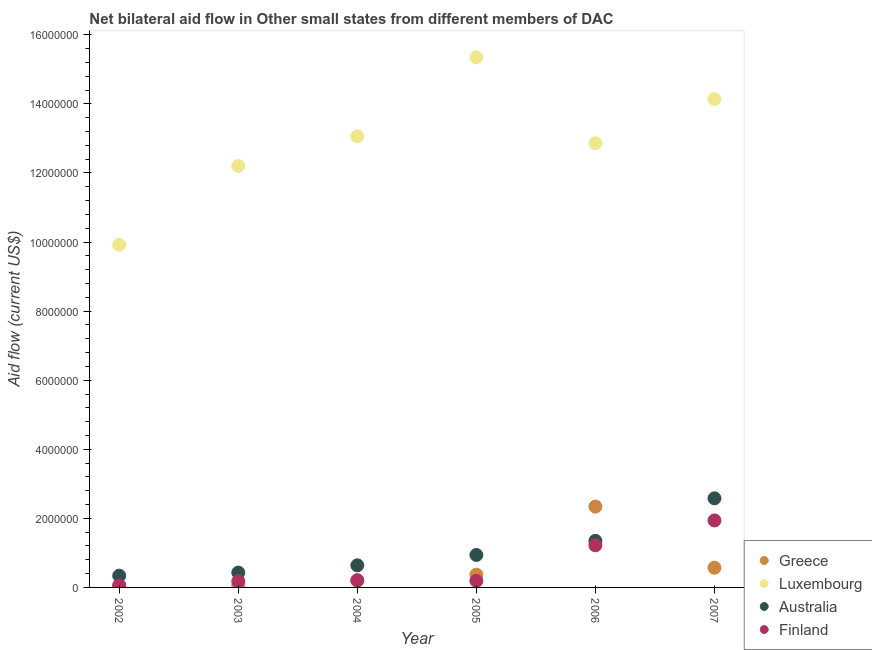Is the number of dotlines equal to the number of legend labels?
Keep it short and to the point. Yes. What is the amount of aid given by greece in 2007?
Your answer should be compact. 5.70e+05. Across all years, what is the maximum amount of aid given by finland?
Keep it short and to the point. 1.94e+06. Across all years, what is the minimum amount of aid given by greece?
Offer a very short reply. 5.00e+04. What is the total amount of aid given by luxembourg in the graph?
Make the answer very short. 7.75e+07. What is the difference between the amount of aid given by luxembourg in 2006 and that in 2007?
Make the answer very short. -1.28e+06. What is the difference between the amount of aid given by australia in 2007 and the amount of aid given by luxembourg in 2006?
Give a very brief answer. -1.03e+07. What is the average amount of aid given by greece per year?
Your answer should be very brief. 5.95e+05. In the year 2002, what is the difference between the amount of aid given by australia and amount of aid given by luxembourg?
Keep it short and to the point. -9.58e+06. In how many years, is the amount of aid given by finland greater than 13200000 US$?
Your response must be concise. 0. What is the ratio of the amount of aid given by greece in 2002 to that in 2006?
Your response must be concise. 0.02. Is the difference between the amount of aid given by luxembourg in 2004 and 2006 greater than the difference between the amount of aid given by finland in 2004 and 2006?
Your answer should be compact. Yes. What is the difference between the highest and the second highest amount of aid given by australia?
Your answer should be very brief. 1.23e+06. What is the difference between the highest and the lowest amount of aid given by greece?
Provide a succinct answer. 2.29e+06. In how many years, is the amount of aid given by australia greater than the average amount of aid given by australia taken over all years?
Provide a short and direct response. 2. Is it the case that in every year, the sum of the amount of aid given by greece and amount of aid given by finland is greater than the sum of amount of aid given by luxembourg and amount of aid given by australia?
Offer a very short reply. No. Is it the case that in every year, the sum of the amount of aid given by greece and amount of aid given by luxembourg is greater than the amount of aid given by australia?
Provide a succinct answer. Yes. Does the amount of aid given by greece monotonically increase over the years?
Offer a very short reply. No. Is the amount of aid given by australia strictly greater than the amount of aid given by greece over the years?
Offer a very short reply. No. Is the amount of aid given by luxembourg strictly less than the amount of aid given by finland over the years?
Provide a succinct answer. No. How many dotlines are there?
Your response must be concise. 4. Are the values on the major ticks of Y-axis written in scientific E-notation?
Make the answer very short. No. Does the graph contain grids?
Your response must be concise. No. Where does the legend appear in the graph?
Ensure brevity in your answer.  Bottom right. How many legend labels are there?
Your answer should be compact. 4. How are the legend labels stacked?
Give a very brief answer. Vertical. What is the title of the graph?
Keep it short and to the point. Net bilateral aid flow in Other small states from different members of DAC. Does "Energy" appear as one of the legend labels in the graph?
Give a very brief answer. No. What is the Aid flow (current US$) of Luxembourg in 2002?
Offer a very short reply. 9.92e+06. What is the Aid flow (current US$) in Australia in 2002?
Offer a very short reply. 3.40e+05. What is the Aid flow (current US$) of Greece in 2003?
Provide a succinct answer. 5.00e+04. What is the Aid flow (current US$) in Luxembourg in 2003?
Offer a very short reply. 1.22e+07. What is the Aid flow (current US$) of Australia in 2003?
Your response must be concise. 4.30e+05. What is the Aid flow (current US$) of Finland in 2003?
Make the answer very short. 1.80e+05. What is the Aid flow (current US$) of Luxembourg in 2004?
Your response must be concise. 1.31e+07. What is the Aid flow (current US$) of Australia in 2004?
Your answer should be very brief. 6.40e+05. What is the Aid flow (current US$) in Luxembourg in 2005?
Offer a very short reply. 1.54e+07. What is the Aid flow (current US$) of Australia in 2005?
Ensure brevity in your answer.  9.40e+05. What is the Aid flow (current US$) in Greece in 2006?
Offer a very short reply. 2.34e+06. What is the Aid flow (current US$) of Luxembourg in 2006?
Your response must be concise. 1.29e+07. What is the Aid flow (current US$) in Australia in 2006?
Give a very brief answer. 1.35e+06. What is the Aid flow (current US$) of Finland in 2006?
Give a very brief answer. 1.22e+06. What is the Aid flow (current US$) in Greece in 2007?
Your response must be concise. 5.70e+05. What is the Aid flow (current US$) in Luxembourg in 2007?
Provide a short and direct response. 1.41e+07. What is the Aid flow (current US$) in Australia in 2007?
Offer a terse response. 2.58e+06. What is the Aid flow (current US$) in Finland in 2007?
Your answer should be compact. 1.94e+06. Across all years, what is the maximum Aid flow (current US$) in Greece?
Your response must be concise. 2.34e+06. Across all years, what is the maximum Aid flow (current US$) in Luxembourg?
Your answer should be compact. 1.54e+07. Across all years, what is the maximum Aid flow (current US$) in Australia?
Your answer should be compact. 2.58e+06. Across all years, what is the maximum Aid flow (current US$) in Finland?
Provide a succinct answer. 1.94e+06. Across all years, what is the minimum Aid flow (current US$) of Greece?
Offer a very short reply. 5.00e+04. Across all years, what is the minimum Aid flow (current US$) in Luxembourg?
Your answer should be very brief. 9.92e+06. Across all years, what is the minimum Aid flow (current US$) in Australia?
Your response must be concise. 3.40e+05. Across all years, what is the minimum Aid flow (current US$) of Finland?
Make the answer very short. 6.00e+04. What is the total Aid flow (current US$) of Greece in the graph?
Offer a very short reply. 3.57e+06. What is the total Aid flow (current US$) of Luxembourg in the graph?
Offer a terse response. 7.75e+07. What is the total Aid flow (current US$) in Australia in the graph?
Give a very brief answer. 6.28e+06. What is the total Aid flow (current US$) of Finland in the graph?
Give a very brief answer. 3.80e+06. What is the difference between the Aid flow (current US$) of Luxembourg in 2002 and that in 2003?
Make the answer very short. -2.28e+06. What is the difference between the Aid flow (current US$) of Greece in 2002 and that in 2004?
Provide a succinct answer. -1.40e+05. What is the difference between the Aid flow (current US$) of Luxembourg in 2002 and that in 2004?
Provide a short and direct response. -3.14e+06. What is the difference between the Aid flow (current US$) of Greece in 2002 and that in 2005?
Keep it short and to the point. -3.20e+05. What is the difference between the Aid flow (current US$) in Luxembourg in 2002 and that in 2005?
Provide a succinct answer. -5.43e+06. What is the difference between the Aid flow (current US$) of Australia in 2002 and that in 2005?
Give a very brief answer. -6.00e+05. What is the difference between the Aid flow (current US$) in Greece in 2002 and that in 2006?
Offer a terse response. -2.29e+06. What is the difference between the Aid flow (current US$) in Luxembourg in 2002 and that in 2006?
Your answer should be very brief. -2.94e+06. What is the difference between the Aid flow (current US$) in Australia in 2002 and that in 2006?
Give a very brief answer. -1.01e+06. What is the difference between the Aid flow (current US$) of Finland in 2002 and that in 2006?
Ensure brevity in your answer.  -1.16e+06. What is the difference between the Aid flow (current US$) in Greece in 2002 and that in 2007?
Your response must be concise. -5.20e+05. What is the difference between the Aid flow (current US$) in Luxembourg in 2002 and that in 2007?
Give a very brief answer. -4.22e+06. What is the difference between the Aid flow (current US$) of Australia in 2002 and that in 2007?
Give a very brief answer. -2.24e+06. What is the difference between the Aid flow (current US$) of Finland in 2002 and that in 2007?
Keep it short and to the point. -1.88e+06. What is the difference between the Aid flow (current US$) in Luxembourg in 2003 and that in 2004?
Your answer should be very brief. -8.60e+05. What is the difference between the Aid flow (current US$) in Australia in 2003 and that in 2004?
Your response must be concise. -2.10e+05. What is the difference between the Aid flow (current US$) of Greece in 2003 and that in 2005?
Your answer should be compact. -3.20e+05. What is the difference between the Aid flow (current US$) in Luxembourg in 2003 and that in 2005?
Give a very brief answer. -3.15e+06. What is the difference between the Aid flow (current US$) in Australia in 2003 and that in 2005?
Offer a very short reply. -5.10e+05. What is the difference between the Aid flow (current US$) of Greece in 2003 and that in 2006?
Your answer should be very brief. -2.29e+06. What is the difference between the Aid flow (current US$) of Luxembourg in 2003 and that in 2006?
Your answer should be very brief. -6.60e+05. What is the difference between the Aid flow (current US$) of Australia in 2003 and that in 2006?
Your answer should be very brief. -9.20e+05. What is the difference between the Aid flow (current US$) of Finland in 2003 and that in 2006?
Provide a short and direct response. -1.04e+06. What is the difference between the Aid flow (current US$) of Greece in 2003 and that in 2007?
Ensure brevity in your answer.  -5.20e+05. What is the difference between the Aid flow (current US$) in Luxembourg in 2003 and that in 2007?
Give a very brief answer. -1.94e+06. What is the difference between the Aid flow (current US$) in Australia in 2003 and that in 2007?
Ensure brevity in your answer.  -2.15e+06. What is the difference between the Aid flow (current US$) in Finland in 2003 and that in 2007?
Keep it short and to the point. -1.76e+06. What is the difference between the Aid flow (current US$) of Luxembourg in 2004 and that in 2005?
Make the answer very short. -2.29e+06. What is the difference between the Aid flow (current US$) in Finland in 2004 and that in 2005?
Provide a succinct answer. 2.00e+04. What is the difference between the Aid flow (current US$) in Greece in 2004 and that in 2006?
Give a very brief answer. -2.15e+06. What is the difference between the Aid flow (current US$) in Australia in 2004 and that in 2006?
Offer a very short reply. -7.10e+05. What is the difference between the Aid flow (current US$) of Finland in 2004 and that in 2006?
Provide a short and direct response. -1.01e+06. What is the difference between the Aid flow (current US$) in Greece in 2004 and that in 2007?
Offer a terse response. -3.80e+05. What is the difference between the Aid flow (current US$) in Luxembourg in 2004 and that in 2007?
Your answer should be very brief. -1.08e+06. What is the difference between the Aid flow (current US$) in Australia in 2004 and that in 2007?
Make the answer very short. -1.94e+06. What is the difference between the Aid flow (current US$) in Finland in 2004 and that in 2007?
Provide a short and direct response. -1.73e+06. What is the difference between the Aid flow (current US$) of Greece in 2005 and that in 2006?
Make the answer very short. -1.97e+06. What is the difference between the Aid flow (current US$) in Luxembourg in 2005 and that in 2006?
Your response must be concise. 2.49e+06. What is the difference between the Aid flow (current US$) in Australia in 2005 and that in 2006?
Your response must be concise. -4.10e+05. What is the difference between the Aid flow (current US$) of Finland in 2005 and that in 2006?
Make the answer very short. -1.03e+06. What is the difference between the Aid flow (current US$) of Luxembourg in 2005 and that in 2007?
Provide a succinct answer. 1.21e+06. What is the difference between the Aid flow (current US$) of Australia in 2005 and that in 2007?
Your response must be concise. -1.64e+06. What is the difference between the Aid flow (current US$) of Finland in 2005 and that in 2007?
Your response must be concise. -1.75e+06. What is the difference between the Aid flow (current US$) in Greece in 2006 and that in 2007?
Ensure brevity in your answer.  1.77e+06. What is the difference between the Aid flow (current US$) in Luxembourg in 2006 and that in 2007?
Your answer should be compact. -1.28e+06. What is the difference between the Aid flow (current US$) of Australia in 2006 and that in 2007?
Offer a very short reply. -1.23e+06. What is the difference between the Aid flow (current US$) of Finland in 2006 and that in 2007?
Your response must be concise. -7.20e+05. What is the difference between the Aid flow (current US$) in Greece in 2002 and the Aid flow (current US$) in Luxembourg in 2003?
Your answer should be very brief. -1.22e+07. What is the difference between the Aid flow (current US$) of Greece in 2002 and the Aid flow (current US$) of Australia in 2003?
Ensure brevity in your answer.  -3.80e+05. What is the difference between the Aid flow (current US$) of Luxembourg in 2002 and the Aid flow (current US$) of Australia in 2003?
Keep it short and to the point. 9.49e+06. What is the difference between the Aid flow (current US$) of Luxembourg in 2002 and the Aid flow (current US$) of Finland in 2003?
Your answer should be very brief. 9.74e+06. What is the difference between the Aid flow (current US$) of Greece in 2002 and the Aid flow (current US$) of Luxembourg in 2004?
Your answer should be very brief. -1.30e+07. What is the difference between the Aid flow (current US$) of Greece in 2002 and the Aid flow (current US$) of Australia in 2004?
Offer a terse response. -5.90e+05. What is the difference between the Aid flow (current US$) in Luxembourg in 2002 and the Aid flow (current US$) in Australia in 2004?
Your answer should be very brief. 9.28e+06. What is the difference between the Aid flow (current US$) of Luxembourg in 2002 and the Aid flow (current US$) of Finland in 2004?
Give a very brief answer. 9.71e+06. What is the difference between the Aid flow (current US$) of Greece in 2002 and the Aid flow (current US$) of Luxembourg in 2005?
Provide a succinct answer. -1.53e+07. What is the difference between the Aid flow (current US$) of Greece in 2002 and the Aid flow (current US$) of Australia in 2005?
Keep it short and to the point. -8.90e+05. What is the difference between the Aid flow (current US$) of Luxembourg in 2002 and the Aid flow (current US$) of Australia in 2005?
Your answer should be very brief. 8.98e+06. What is the difference between the Aid flow (current US$) in Luxembourg in 2002 and the Aid flow (current US$) in Finland in 2005?
Offer a very short reply. 9.73e+06. What is the difference between the Aid flow (current US$) of Greece in 2002 and the Aid flow (current US$) of Luxembourg in 2006?
Make the answer very short. -1.28e+07. What is the difference between the Aid flow (current US$) of Greece in 2002 and the Aid flow (current US$) of Australia in 2006?
Give a very brief answer. -1.30e+06. What is the difference between the Aid flow (current US$) of Greece in 2002 and the Aid flow (current US$) of Finland in 2006?
Your answer should be very brief. -1.17e+06. What is the difference between the Aid flow (current US$) in Luxembourg in 2002 and the Aid flow (current US$) in Australia in 2006?
Offer a very short reply. 8.57e+06. What is the difference between the Aid flow (current US$) of Luxembourg in 2002 and the Aid flow (current US$) of Finland in 2006?
Your response must be concise. 8.70e+06. What is the difference between the Aid flow (current US$) in Australia in 2002 and the Aid flow (current US$) in Finland in 2006?
Offer a terse response. -8.80e+05. What is the difference between the Aid flow (current US$) in Greece in 2002 and the Aid flow (current US$) in Luxembourg in 2007?
Your answer should be compact. -1.41e+07. What is the difference between the Aid flow (current US$) of Greece in 2002 and the Aid flow (current US$) of Australia in 2007?
Make the answer very short. -2.53e+06. What is the difference between the Aid flow (current US$) of Greece in 2002 and the Aid flow (current US$) of Finland in 2007?
Offer a terse response. -1.89e+06. What is the difference between the Aid flow (current US$) of Luxembourg in 2002 and the Aid flow (current US$) of Australia in 2007?
Offer a terse response. 7.34e+06. What is the difference between the Aid flow (current US$) in Luxembourg in 2002 and the Aid flow (current US$) in Finland in 2007?
Provide a short and direct response. 7.98e+06. What is the difference between the Aid flow (current US$) of Australia in 2002 and the Aid flow (current US$) of Finland in 2007?
Your answer should be compact. -1.60e+06. What is the difference between the Aid flow (current US$) in Greece in 2003 and the Aid flow (current US$) in Luxembourg in 2004?
Keep it short and to the point. -1.30e+07. What is the difference between the Aid flow (current US$) of Greece in 2003 and the Aid flow (current US$) of Australia in 2004?
Your answer should be very brief. -5.90e+05. What is the difference between the Aid flow (current US$) in Greece in 2003 and the Aid flow (current US$) in Finland in 2004?
Your response must be concise. -1.60e+05. What is the difference between the Aid flow (current US$) of Luxembourg in 2003 and the Aid flow (current US$) of Australia in 2004?
Provide a short and direct response. 1.16e+07. What is the difference between the Aid flow (current US$) in Luxembourg in 2003 and the Aid flow (current US$) in Finland in 2004?
Offer a very short reply. 1.20e+07. What is the difference between the Aid flow (current US$) of Australia in 2003 and the Aid flow (current US$) of Finland in 2004?
Offer a terse response. 2.20e+05. What is the difference between the Aid flow (current US$) of Greece in 2003 and the Aid flow (current US$) of Luxembourg in 2005?
Ensure brevity in your answer.  -1.53e+07. What is the difference between the Aid flow (current US$) of Greece in 2003 and the Aid flow (current US$) of Australia in 2005?
Your answer should be compact. -8.90e+05. What is the difference between the Aid flow (current US$) in Luxembourg in 2003 and the Aid flow (current US$) in Australia in 2005?
Your answer should be very brief. 1.13e+07. What is the difference between the Aid flow (current US$) in Luxembourg in 2003 and the Aid flow (current US$) in Finland in 2005?
Ensure brevity in your answer.  1.20e+07. What is the difference between the Aid flow (current US$) of Greece in 2003 and the Aid flow (current US$) of Luxembourg in 2006?
Ensure brevity in your answer.  -1.28e+07. What is the difference between the Aid flow (current US$) in Greece in 2003 and the Aid flow (current US$) in Australia in 2006?
Offer a very short reply. -1.30e+06. What is the difference between the Aid flow (current US$) of Greece in 2003 and the Aid flow (current US$) of Finland in 2006?
Offer a terse response. -1.17e+06. What is the difference between the Aid flow (current US$) of Luxembourg in 2003 and the Aid flow (current US$) of Australia in 2006?
Make the answer very short. 1.08e+07. What is the difference between the Aid flow (current US$) in Luxembourg in 2003 and the Aid flow (current US$) in Finland in 2006?
Offer a very short reply. 1.10e+07. What is the difference between the Aid flow (current US$) in Australia in 2003 and the Aid flow (current US$) in Finland in 2006?
Offer a terse response. -7.90e+05. What is the difference between the Aid flow (current US$) in Greece in 2003 and the Aid flow (current US$) in Luxembourg in 2007?
Keep it short and to the point. -1.41e+07. What is the difference between the Aid flow (current US$) of Greece in 2003 and the Aid flow (current US$) of Australia in 2007?
Your answer should be very brief. -2.53e+06. What is the difference between the Aid flow (current US$) of Greece in 2003 and the Aid flow (current US$) of Finland in 2007?
Keep it short and to the point. -1.89e+06. What is the difference between the Aid flow (current US$) of Luxembourg in 2003 and the Aid flow (current US$) of Australia in 2007?
Keep it short and to the point. 9.62e+06. What is the difference between the Aid flow (current US$) of Luxembourg in 2003 and the Aid flow (current US$) of Finland in 2007?
Ensure brevity in your answer.  1.03e+07. What is the difference between the Aid flow (current US$) in Australia in 2003 and the Aid flow (current US$) in Finland in 2007?
Offer a very short reply. -1.51e+06. What is the difference between the Aid flow (current US$) of Greece in 2004 and the Aid flow (current US$) of Luxembourg in 2005?
Your response must be concise. -1.52e+07. What is the difference between the Aid flow (current US$) in Greece in 2004 and the Aid flow (current US$) in Australia in 2005?
Your response must be concise. -7.50e+05. What is the difference between the Aid flow (current US$) of Greece in 2004 and the Aid flow (current US$) of Finland in 2005?
Your answer should be very brief. 0. What is the difference between the Aid flow (current US$) in Luxembourg in 2004 and the Aid flow (current US$) in Australia in 2005?
Provide a succinct answer. 1.21e+07. What is the difference between the Aid flow (current US$) of Luxembourg in 2004 and the Aid flow (current US$) of Finland in 2005?
Provide a short and direct response. 1.29e+07. What is the difference between the Aid flow (current US$) in Greece in 2004 and the Aid flow (current US$) in Luxembourg in 2006?
Provide a short and direct response. -1.27e+07. What is the difference between the Aid flow (current US$) of Greece in 2004 and the Aid flow (current US$) of Australia in 2006?
Give a very brief answer. -1.16e+06. What is the difference between the Aid flow (current US$) in Greece in 2004 and the Aid flow (current US$) in Finland in 2006?
Your response must be concise. -1.03e+06. What is the difference between the Aid flow (current US$) in Luxembourg in 2004 and the Aid flow (current US$) in Australia in 2006?
Provide a short and direct response. 1.17e+07. What is the difference between the Aid flow (current US$) in Luxembourg in 2004 and the Aid flow (current US$) in Finland in 2006?
Your answer should be compact. 1.18e+07. What is the difference between the Aid flow (current US$) of Australia in 2004 and the Aid flow (current US$) of Finland in 2006?
Give a very brief answer. -5.80e+05. What is the difference between the Aid flow (current US$) of Greece in 2004 and the Aid flow (current US$) of Luxembourg in 2007?
Your answer should be compact. -1.40e+07. What is the difference between the Aid flow (current US$) of Greece in 2004 and the Aid flow (current US$) of Australia in 2007?
Your answer should be very brief. -2.39e+06. What is the difference between the Aid flow (current US$) in Greece in 2004 and the Aid flow (current US$) in Finland in 2007?
Offer a very short reply. -1.75e+06. What is the difference between the Aid flow (current US$) of Luxembourg in 2004 and the Aid flow (current US$) of Australia in 2007?
Provide a short and direct response. 1.05e+07. What is the difference between the Aid flow (current US$) in Luxembourg in 2004 and the Aid flow (current US$) in Finland in 2007?
Ensure brevity in your answer.  1.11e+07. What is the difference between the Aid flow (current US$) in Australia in 2004 and the Aid flow (current US$) in Finland in 2007?
Give a very brief answer. -1.30e+06. What is the difference between the Aid flow (current US$) of Greece in 2005 and the Aid flow (current US$) of Luxembourg in 2006?
Keep it short and to the point. -1.25e+07. What is the difference between the Aid flow (current US$) in Greece in 2005 and the Aid flow (current US$) in Australia in 2006?
Offer a very short reply. -9.80e+05. What is the difference between the Aid flow (current US$) of Greece in 2005 and the Aid flow (current US$) of Finland in 2006?
Your response must be concise. -8.50e+05. What is the difference between the Aid flow (current US$) of Luxembourg in 2005 and the Aid flow (current US$) of Australia in 2006?
Your answer should be compact. 1.40e+07. What is the difference between the Aid flow (current US$) of Luxembourg in 2005 and the Aid flow (current US$) of Finland in 2006?
Offer a terse response. 1.41e+07. What is the difference between the Aid flow (current US$) in Australia in 2005 and the Aid flow (current US$) in Finland in 2006?
Keep it short and to the point. -2.80e+05. What is the difference between the Aid flow (current US$) in Greece in 2005 and the Aid flow (current US$) in Luxembourg in 2007?
Ensure brevity in your answer.  -1.38e+07. What is the difference between the Aid flow (current US$) in Greece in 2005 and the Aid flow (current US$) in Australia in 2007?
Ensure brevity in your answer.  -2.21e+06. What is the difference between the Aid flow (current US$) in Greece in 2005 and the Aid flow (current US$) in Finland in 2007?
Offer a very short reply. -1.57e+06. What is the difference between the Aid flow (current US$) in Luxembourg in 2005 and the Aid flow (current US$) in Australia in 2007?
Your answer should be very brief. 1.28e+07. What is the difference between the Aid flow (current US$) in Luxembourg in 2005 and the Aid flow (current US$) in Finland in 2007?
Ensure brevity in your answer.  1.34e+07. What is the difference between the Aid flow (current US$) in Greece in 2006 and the Aid flow (current US$) in Luxembourg in 2007?
Ensure brevity in your answer.  -1.18e+07. What is the difference between the Aid flow (current US$) in Luxembourg in 2006 and the Aid flow (current US$) in Australia in 2007?
Offer a terse response. 1.03e+07. What is the difference between the Aid flow (current US$) in Luxembourg in 2006 and the Aid flow (current US$) in Finland in 2007?
Offer a terse response. 1.09e+07. What is the difference between the Aid flow (current US$) of Australia in 2006 and the Aid flow (current US$) of Finland in 2007?
Provide a short and direct response. -5.90e+05. What is the average Aid flow (current US$) in Greece per year?
Your response must be concise. 5.95e+05. What is the average Aid flow (current US$) of Luxembourg per year?
Provide a short and direct response. 1.29e+07. What is the average Aid flow (current US$) of Australia per year?
Provide a short and direct response. 1.05e+06. What is the average Aid flow (current US$) of Finland per year?
Offer a very short reply. 6.33e+05. In the year 2002, what is the difference between the Aid flow (current US$) of Greece and Aid flow (current US$) of Luxembourg?
Give a very brief answer. -9.87e+06. In the year 2002, what is the difference between the Aid flow (current US$) in Greece and Aid flow (current US$) in Finland?
Provide a succinct answer. -10000. In the year 2002, what is the difference between the Aid flow (current US$) in Luxembourg and Aid flow (current US$) in Australia?
Keep it short and to the point. 9.58e+06. In the year 2002, what is the difference between the Aid flow (current US$) in Luxembourg and Aid flow (current US$) in Finland?
Give a very brief answer. 9.86e+06. In the year 2003, what is the difference between the Aid flow (current US$) in Greece and Aid flow (current US$) in Luxembourg?
Offer a very short reply. -1.22e+07. In the year 2003, what is the difference between the Aid flow (current US$) of Greece and Aid flow (current US$) of Australia?
Keep it short and to the point. -3.80e+05. In the year 2003, what is the difference between the Aid flow (current US$) in Luxembourg and Aid flow (current US$) in Australia?
Offer a terse response. 1.18e+07. In the year 2003, what is the difference between the Aid flow (current US$) of Luxembourg and Aid flow (current US$) of Finland?
Offer a very short reply. 1.20e+07. In the year 2004, what is the difference between the Aid flow (current US$) of Greece and Aid flow (current US$) of Luxembourg?
Your answer should be compact. -1.29e+07. In the year 2004, what is the difference between the Aid flow (current US$) of Greece and Aid flow (current US$) of Australia?
Ensure brevity in your answer.  -4.50e+05. In the year 2004, what is the difference between the Aid flow (current US$) of Luxembourg and Aid flow (current US$) of Australia?
Your response must be concise. 1.24e+07. In the year 2004, what is the difference between the Aid flow (current US$) of Luxembourg and Aid flow (current US$) of Finland?
Offer a terse response. 1.28e+07. In the year 2005, what is the difference between the Aid flow (current US$) of Greece and Aid flow (current US$) of Luxembourg?
Give a very brief answer. -1.50e+07. In the year 2005, what is the difference between the Aid flow (current US$) of Greece and Aid flow (current US$) of Australia?
Provide a succinct answer. -5.70e+05. In the year 2005, what is the difference between the Aid flow (current US$) of Greece and Aid flow (current US$) of Finland?
Provide a short and direct response. 1.80e+05. In the year 2005, what is the difference between the Aid flow (current US$) of Luxembourg and Aid flow (current US$) of Australia?
Keep it short and to the point. 1.44e+07. In the year 2005, what is the difference between the Aid flow (current US$) of Luxembourg and Aid flow (current US$) of Finland?
Your answer should be very brief. 1.52e+07. In the year 2005, what is the difference between the Aid flow (current US$) of Australia and Aid flow (current US$) of Finland?
Offer a very short reply. 7.50e+05. In the year 2006, what is the difference between the Aid flow (current US$) in Greece and Aid flow (current US$) in Luxembourg?
Give a very brief answer. -1.05e+07. In the year 2006, what is the difference between the Aid flow (current US$) of Greece and Aid flow (current US$) of Australia?
Your response must be concise. 9.90e+05. In the year 2006, what is the difference between the Aid flow (current US$) of Greece and Aid flow (current US$) of Finland?
Provide a short and direct response. 1.12e+06. In the year 2006, what is the difference between the Aid flow (current US$) in Luxembourg and Aid flow (current US$) in Australia?
Your response must be concise. 1.15e+07. In the year 2006, what is the difference between the Aid flow (current US$) of Luxembourg and Aid flow (current US$) of Finland?
Provide a short and direct response. 1.16e+07. In the year 2006, what is the difference between the Aid flow (current US$) of Australia and Aid flow (current US$) of Finland?
Provide a short and direct response. 1.30e+05. In the year 2007, what is the difference between the Aid flow (current US$) of Greece and Aid flow (current US$) of Luxembourg?
Your response must be concise. -1.36e+07. In the year 2007, what is the difference between the Aid flow (current US$) of Greece and Aid flow (current US$) of Australia?
Provide a short and direct response. -2.01e+06. In the year 2007, what is the difference between the Aid flow (current US$) of Greece and Aid flow (current US$) of Finland?
Your response must be concise. -1.37e+06. In the year 2007, what is the difference between the Aid flow (current US$) of Luxembourg and Aid flow (current US$) of Australia?
Your answer should be very brief. 1.16e+07. In the year 2007, what is the difference between the Aid flow (current US$) in Luxembourg and Aid flow (current US$) in Finland?
Your answer should be compact. 1.22e+07. In the year 2007, what is the difference between the Aid flow (current US$) in Australia and Aid flow (current US$) in Finland?
Provide a succinct answer. 6.40e+05. What is the ratio of the Aid flow (current US$) in Greece in 2002 to that in 2003?
Your answer should be compact. 1. What is the ratio of the Aid flow (current US$) in Luxembourg in 2002 to that in 2003?
Offer a very short reply. 0.81. What is the ratio of the Aid flow (current US$) in Australia in 2002 to that in 2003?
Offer a very short reply. 0.79. What is the ratio of the Aid flow (current US$) in Finland in 2002 to that in 2003?
Your response must be concise. 0.33. What is the ratio of the Aid flow (current US$) of Greece in 2002 to that in 2004?
Your answer should be compact. 0.26. What is the ratio of the Aid flow (current US$) of Luxembourg in 2002 to that in 2004?
Your response must be concise. 0.76. What is the ratio of the Aid flow (current US$) in Australia in 2002 to that in 2004?
Give a very brief answer. 0.53. What is the ratio of the Aid flow (current US$) in Finland in 2002 to that in 2004?
Keep it short and to the point. 0.29. What is the ratio of the Aid flow (current US$) of Greece in 2002 to that in 2005?
Offer a very short reply. 0.14. What is the ratio of the Aid flow (current US$) in Luxembourg in 2002 to that in 2005?
Make the answer very short. 0.65. What is the ratio of the Aid flow (current US$) of Australia in 2002 to that in 2005?
Make the answer very short. 0.36. What is the ratio of the Aid flow (current US$) of Finland in 2002 to that in 2005?
Your response must be concise. 0.32. What is the ratio of the Aid flow (current US$) in Greece in 2002 to that in 2006?
Offer a terse response. 0.02. What is the ratio of the Aid flow (current US$) in Luxembourg in 2002 to that in 2006?
Provide a short and direct response. 0.77. What is the ratio of the Aid flow (current US$) of Australia in 2002 to that in 2006?
Give a very brief answer. 0.25. What is the ratio of the Aid flow (current US$) in Finland in 2002 to that in 2006?
Provide a succinct answer. 0.05. What is the ratio of the Aid flow (current US$) of Greece in 2002 to that in 2007?
Your response must be concise. 0.09. What is the ratio of the Aid flow (current US$) of Luxembourg in 2002 to that in 2007?
Your response must be concise. 0.7. What is the ratio of the Aid flow (current US$) of Australia in 2002 to that in 2007?
Offer a terse response. 0.13. What is the ratio of the Aid flow (current US$) in Finland in 2002 to that in 2007?
Offer a terse response. 0.03. What is the ratio of the Aid flow (current US$) in Greece in 2003 to that in 2004?
Offer a terse response. 0.26. What is the ratio of the Aid flow (current US$) of Luxembourg in 2003 to that in 2004?
Your answer should be very brief. 0.93. What is the ratio of the Aid flow (current US$) of Australia in 2003 to that in 2004?
Make the answer very short. 0.67. What is the ratio of the Aid flow (current US$) in Greece in 2003 to that in 2005?
Your response must be concise. 0.14. What is the ratio of the Aid flow (current US$) of Luxembourg in 2003 to that in 2005?
Your answer should be compact. 0.79. What is the ratio of the Aid flow (current US$) of Australia in 2003 to that in 2005?
Provide a succinct answer. 0.46. What is the ratio of the Aid flow (current US$) in Greece in 2003 to that in 2006?
Provide a succinct answer. 0.02. What is the ratio of the Aid flow (current US$) of Luxembourg in 2003 to that in 2006?
Ensure brevity in your answer.  0.95. What is the ratio of the Aid flow (current US$) of Australia in 2003 to that in 2006?
Make the answer very short. 0.32. What is the ratio of the Aid flow (current US$) in Finland in 2003 to that in 2006?
Your answer should be very brief. 0.15. What is the ratio of the Aid flow (current US$) of Greece in 2003 to that in 2007?
Keep it short and to the point. 0.09. What is the ratio of the Aid flow (current US$) of Luxembourg in 2003 to that in 2007?
Your answer should be very brief. 0.86. What is the ratio of the Aid flow (current US$) of Australia in 2003 to that in 2007?
Ensure brevity in your answer.  0.17. What is the ratio of the Aid flow (current US$) of Finland in 2003 to that in 2007?
Provide a succinct answer. 0.09. What is the ratio of the Aid flow (current US$) in Greece in 2004 to that in 2005?
Your answer should be very brief. 0.51. What is the ratio of the Aid flow (current US$) of Luxembourg in 2004 to that in 2005?
Provide a short and direct response. 0.85. What is the ratio of the Aid flow (current US$) in Australia in 2004 to that in 2005?
Provide a succinct answer. 0.68. What is the ratio of the Aid flow (current US$) of Finland in 2004 to that in 2005?
Provide a short and direct response. 1.11. What is the ratio of the Aid flow (current US$) in Greece in 2004 to that in 2006?
Provide a succinct answer. 0.08. What is the ratio of the Aid flow (current US$) in Luxembourg in 2004 to that in 2006?
Keep it short and to the point. 1.02. What is the ratio of the Aid flow (current US$) of Australia in 2004 to that in 2006?
Your response must be concise. 0.47. What is the ratio of the Aid flow (current US$) in Finland in 2004 to that in 2006?
Provide a short and direct response. 0.17. What is the ratio of the Aid flow (current US$) in Luxembourg in 2004 to that in 2007?
Provide a short and direct response. 0.92. What is the ratio of the Aid flow (current US$) of Australia in 2004 to that in 2007?
Offer a very short reply. 0.25. What is the ratio of the Aid flow (current US$) in Finland in 2004 to that in 2007?
Provide a short and direct response. 0.11. What is the ratio of the Aid flow (current US$) of Greece in 2005 to that in 2006?
Provide a short and direct response. 0.16. What is the ratio of the Aid flow (current US$) in Luxembourg in 2005 to that in 2006?
Give a very brief answer. 1.19. What is the ratio of the Aid flow (current US$) in Australia in 2005 to that in 2006?
Keep it short and to the point. 0.7. What is the ratio of the Aid flow (current US$) of Finland in 2005 to that in 2006?
Ensure brevity in your answer.  0.16. What is the ratio of the Aid flow (current US$) of Greece in 2005 to that in 2007?
Your answer should be compact. 0.65. What is the ratio of the Aid flow (current US$) of Luxembourg in 2005 to that in 2007?
Give a very brief answer. 1.09. What is the ratio of the Aid flow (current US$) of Australia in 2005 to that in 2007?
Your answer should be very brief. 0.36. What is the ratio of the Aid flow (current US$) of Finland in 2005 to that in 2007?
Your answer should be compact. 0.1. What is the ratio of the Aid flow (current US$) of Greece in 2006 to that in 2007?
Your answer should be very brief. 4.11. What is the ratio of the Aid flow (current US$) in Luxembourg in 2006 to that in 2007?
Make the answer very short. 0.91. What is the ratio of the Aid flow (current US$) in Australia in 2006 to that in 2007?
Your answer should be very brief. 0.52. What is the ratio of the Aid flow (current US$) in Finland in 2006 to that in 2007?
Offer a very short reply. 0.63. What is the difference between the highest and the second highest Aid flow (current US$) of Greece?
Provide a succinct answer. 1.77e+06. What is the difference between the highest and the second highest Aid flow (current US$) in Luxembourg?
Ensure brevity in your answer.  1.21e+06. What is the difference between the highest and the second highest Aid flow (current US$) of Australia?
Your answer should be compact. 1.23e+06. What is the difference between the highest and the second highest Aid flow (current US$) of Finland?
Offer a terse response. 7.20e+05. What is the difference between the highest and the lowest Aid flow (current US$) of Greece?
Give a very brief answer. 2.29e+06. What is the difference between the highest and the lowest Aid flow (current US$) in Luxembourg?
Give a very brief answer. 5.43e+06. What is the difference between the highest and the lowest Aid flow (current US$) in Australia?
Your response must be concise. 2.24e+06. What is the difference between the highest and the lowest Aid flow (current US$) of Finland?
Your answer should be very brief. 1.88e+06. 